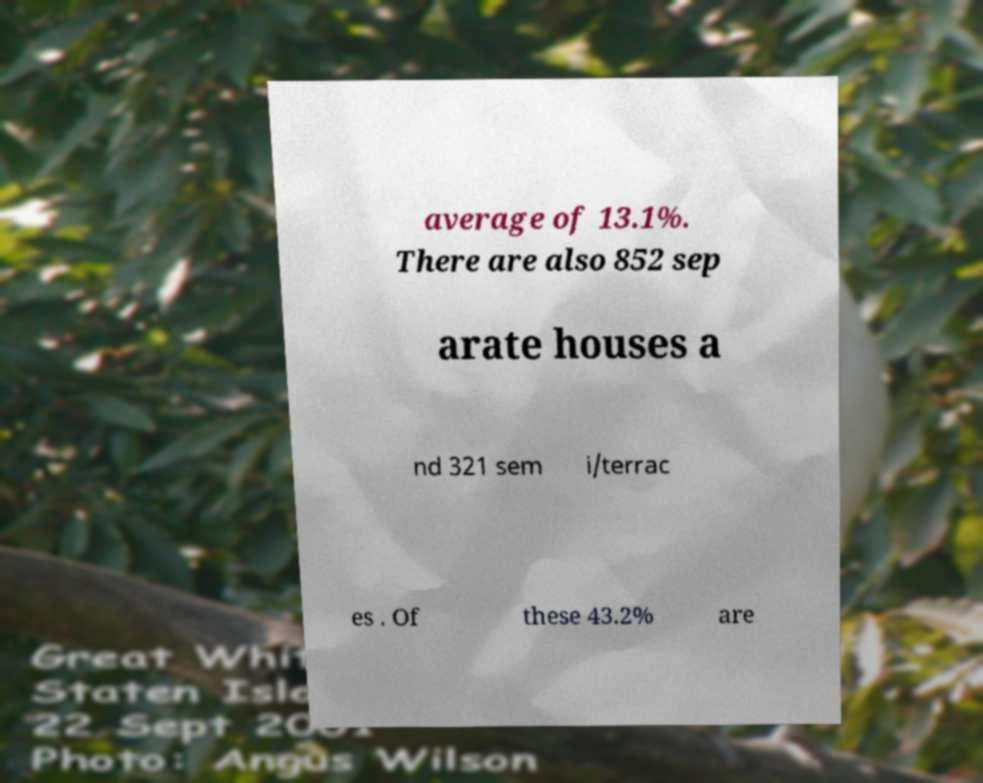I need the written content from this picture converted into text. Can you do that? average of 13.1%. There are also 852 sep arate houses a nd 321 sem i/terrac es . Of these 43.2% are 